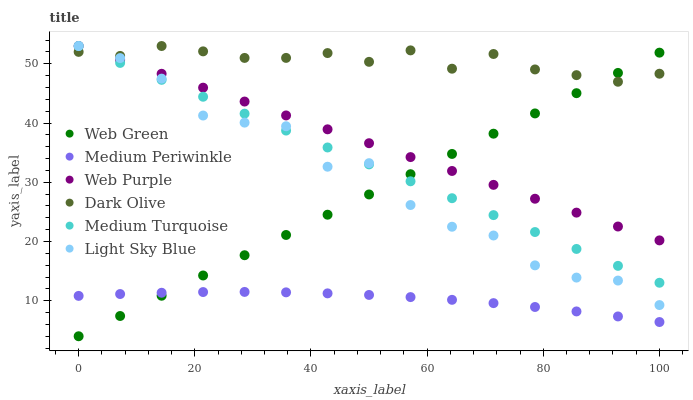Does Medium Periwinkle have the minimum area under the curve?
Answer yes or no. Yes. Does Dark Olive have the maximum area under the curve?
Answer yes or no. Yes. Does Web Green have the minimum area under the curve?
Answer yes or no. No. Does Web Green have the maximum area under the curve?
Answer yes or no. No. Is Web Green the smoothest?
Answer yes or no. Yes. Is Light Sky Blue the roughest?
Answer yes or no. Yes. Is Medium Periwinkle the smoothest?
Answer yes or no. No. Is Medium Periwinkle the roughest?
Answer yes or no. No. Does Web Green have the lowest value?
Answer yes or no. Yes. Does Medium Periwinkle have the lowest value?
Answer yes or no. No. Does Medium Turquoise have the highest value?
Answer yes or no. Yes. Does Web Green have the highest value?
Answer yes or no. No. Is Medium Periwinkle less than Medium Turquoise?
Answer yes or no. Yes. Is Dark Olive greater than Medium Periwinkle?
Answer yes or no. Yes. Does Web Green intersect Dark Olive?
Answer yes or no. Yes. Is Web Green less than Dark Olive?
Answer yes or no. No. Is Web Green greater than Dark Olive?
Answer yes or no. No. Does Medium Periwinkle intersect Medium Turquoise?
Answer yes or no. No. 